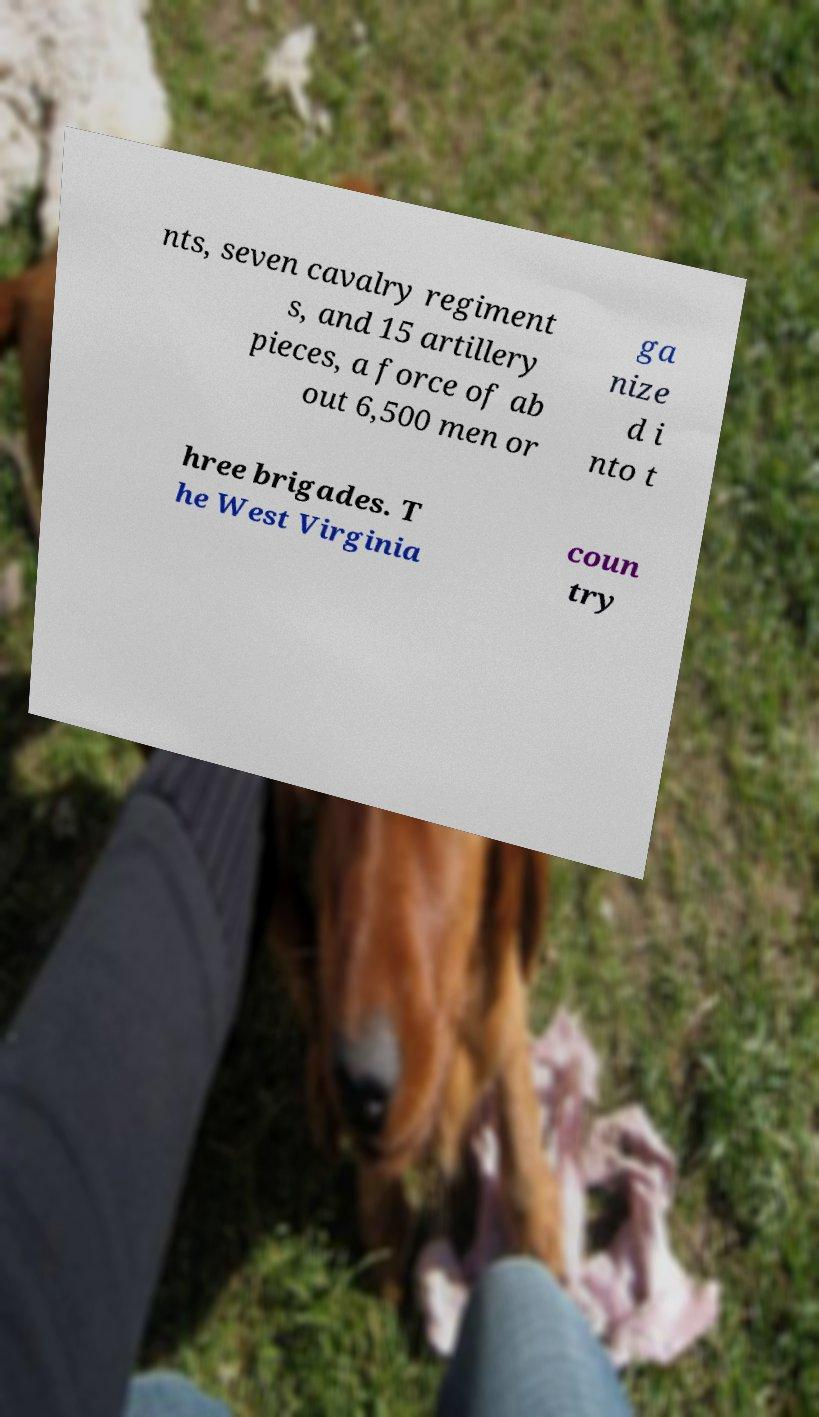I need the written content from this picture converted into text. Can you do that? nts, seven cavalry regiment s, and 15 artillery pieces, a force of ab out 6,500 men or ga nize d i nto t hree brigades. T he West Virginia coun try 